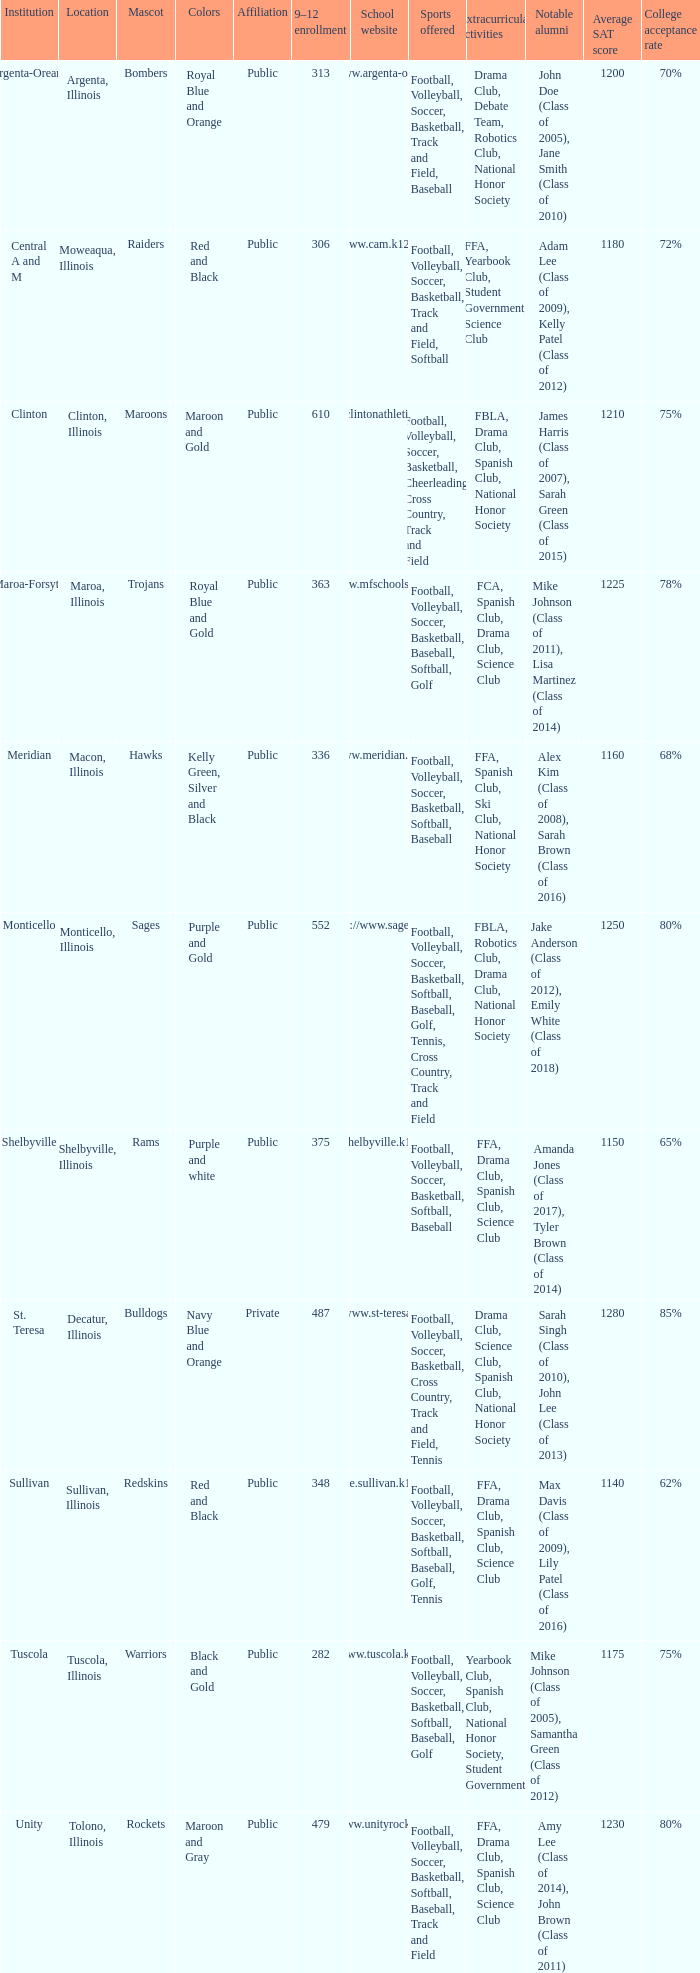Could you help me parse every detail presented in this table? {'header': ['Institution', 'Location', 'Mascot', 'Colors', 'Affiliation', '9–12 enrollment', 'School website', 'Sports offered', 'Extracurricular activities', 'Notable alumni', 'Average SAT score', 'College acceptance rate '], 'rows': [['Argenta-Oreana', 'Argenta, Illinois', 'Bombers', 'Royal Blue and Orange', 'Public', '313', 'http://www.argenta-oreana.org', 'Football, Volleyball, Soccer, Basketball, Track and Field, Baseball', 'Drama Club, Debate Team, Robotics Club, National Honor Society', 'John Doe (Class of 2005), Jane Smith (Class of 2010)', '1200', '70%'], ['Central A and M', 'Moweaqua, Illinois', 'Raiders', 'Red and Black', 'Public', '306', 'http://www.cam.k12.il.us/hs', 'Football, Volleyball, Soccer, Basketball, Track and Field, Softball', 'FFA, Yearbook Club, Student Government, Science Club', 'Adam Lee (Class of 2009), Kelly Patel (Class of 2012)', '1180', '72%'], ['Clinton', 'Clinton, Illinois', 'Maroons', 'Maroon and Gold', 'Public', '610', 'http://clintonathletics.com', 'Football, Volleyball, Soccer, Basketball, Cheerleading, Cross Country, Track and Field', 'FBLA, Drama Club, Spanish Club, National Honor Society', 'James Harris (Class of 2007), Sarah Green (Class of 2015)', '1210', '75%'], ['Maroa-Forsyth', 'Maroa, Illinois', 'Trojans', 'Royal Blue and Gold', 'Public', '363', 'http://www.mfschools.org/high/', 'Football, Volleyball, Soccer, Basketball, Baseball, Softball, Golf', 'FCA, Spanish Club, Drama Club, Science Club', 'Mike Johnson (Class of 2011), Lisa Martinez (Class of 2014)', '1225', '78%'], ['Meridian', 'Macon, Illinois', 'Hawks', 'Kelly Green, Silver and Black', 'Public', '336', 'http://www.meridian.k12.il.us/', 'Football, Volleyball, Soccer, Basketball, Softball, Baseball', 'FFA, Spanish Club, Ski Club, National Honor Society', 'Alex Kim (Class of 2008), Sarah Brown (Class of 2016)', '1160', '68%'], ['Monticello', 'Monticello, Illinois', 'Sages', 'Purple and Gold', 'Public', '552', 'http://www.sages.us', 'Football, Volleyball, Soccer, Basketball, Softball, Baseball, Golf, Tennis, Cross Country, Track and Field', 'FBLA, Robotics Club, Drama Club, National Honor Society', 'Jake Anderson (Class of 2012), Emily White (Class of 2018)', '1250', '80%'], ['Shelbyville', 'Shelbyville, Illinois', 'Rams', 'Purple and white', 'Public', '375', 'http://shelbyville.k12.il.us/', 'Football, Volleyball, Soccer, Basketball, Softball, Baseball', 'FFA, Drama Club, Spanish Club, Science Club', 'Amanda Jones (Class of 2017), Tyler Brown (Class of 2014)', '1150', '65%'], ['St. Teresa', 'Decatur, Illinois', 'Bulldogs', 'Navy Blue and Orange', 'Private', '487', 'http://www.st-teresahs.org/', 'Football, Volleyball, Soccer, Basketball, Cross Country, Track and Field, Tennis', 'Drama Club, Science Club, Spanish Club, National Honor Society', 'Sarah Singh (Class of 2010), John Lee (Class of 2013)', '1280', '85%'], ['Sullivan', 'Sullivan, Illinois', 'Redskins', 'Red and Black', 'Public', '348', 'http://home.sullivan.k12.il.us/shs', 'Football, Volleyball, Soccer, Basketball, Softball, Baseball, Golf, Tennis', 'FFA, Drama Club, Spanish Club, Science Club', 'Max Davis (Class of 2009), Lily Patel (Class of 2016)', '1140', '62%'], ['Tuscola', 'Tuscola, Illinois', 'Warriors', 'Black and Gold', 'Public', '282', 'http://www.tuscola.k12.il.us/', 'Football, Volleyball, Soccer, Basketball, Softball, Baseball, Golf', 'Yearbook Club, Spanish Club, National Honor Society, Student Government', 'Mike Johnson (Class of 2005), Samantha Green (Class of 2012)', '1175', '75%'], ['Unity', 'Tolono, Illinois', 'Rockets', 'Maroon and Gray', 'Public', '479', 'http://www.unityrockets.com/', 'Football, Volleyball, Soccer, Basketball, Softball, Baseball, Track and Field', 'FFA, Drama Club, Spanish Club, Science Club', 'Amy Lee (Class of 2014), John Brown (Class of 2011)', '1230', '80%']]} What colors can you see players from Tolono, Illinois wearing? Maroon and Gray. 